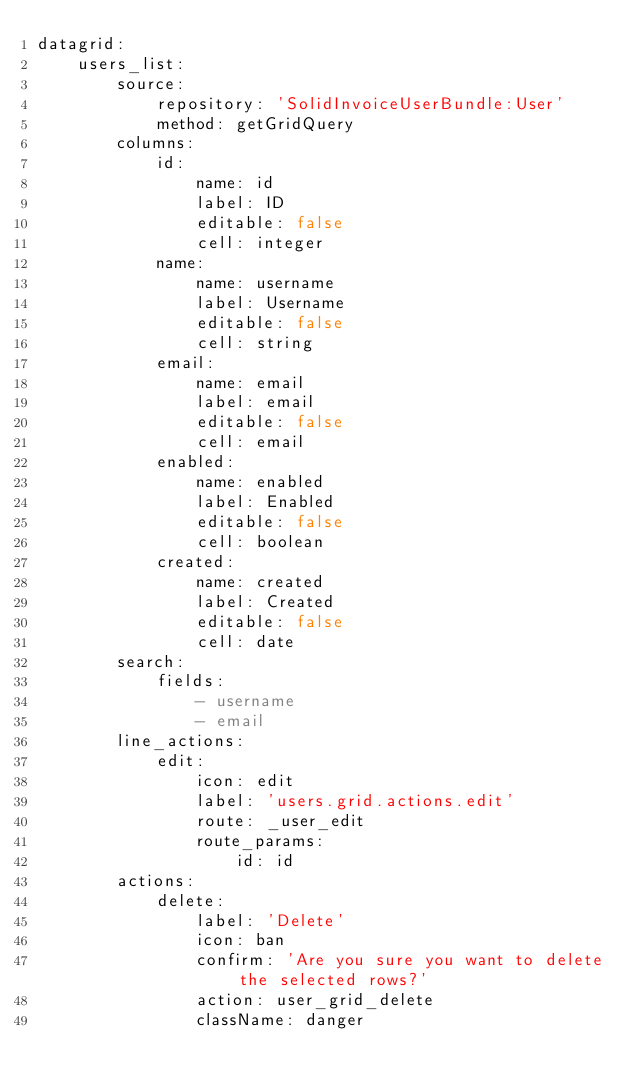Convert code to text. <code><loc_0><loc_0><loc_500><loc_500><_YAML_>datagrid:
    users_list:
        source:
            repository: 'SolidInvoiceUserBundle:User'
            method: getGridQuery
        columns:
            id:
                name: id
                label: ID
                editable: false
                cell: integer
            name:
                name: username
                label: Username
                editable: false
                cell: string
            email:
                name: email
                label: email
                editable: false
                cell: email
            enabled:
                name: enabled
                label: Enabled
                editable: false
                cell: boolean
            created:
                name: created
                label: Created
                editable: false
                cell: date
        search:
            fields:
                - username
                - email
        line_actions:
            edit:
                icon: edit
                label: 'users.grid.actions.edit'
                route: _user_edit
                route_params:
                    id: id
        actions:
            delete:
                label: 'Delete'
                icon: ban
                confirm: 'Are you sure you want to delete the selected rows?'
                action: user_grid_delete
                className: danger
</code> 